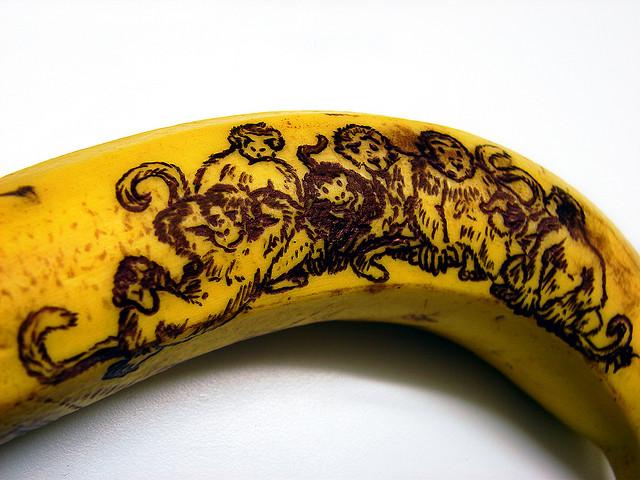What fruit is shown?
Quick response, please. Banana. Could these depictions be monkeys on a banana skin?
Short answer required. Yes. How many monkeys?
Short answer required. 6. 